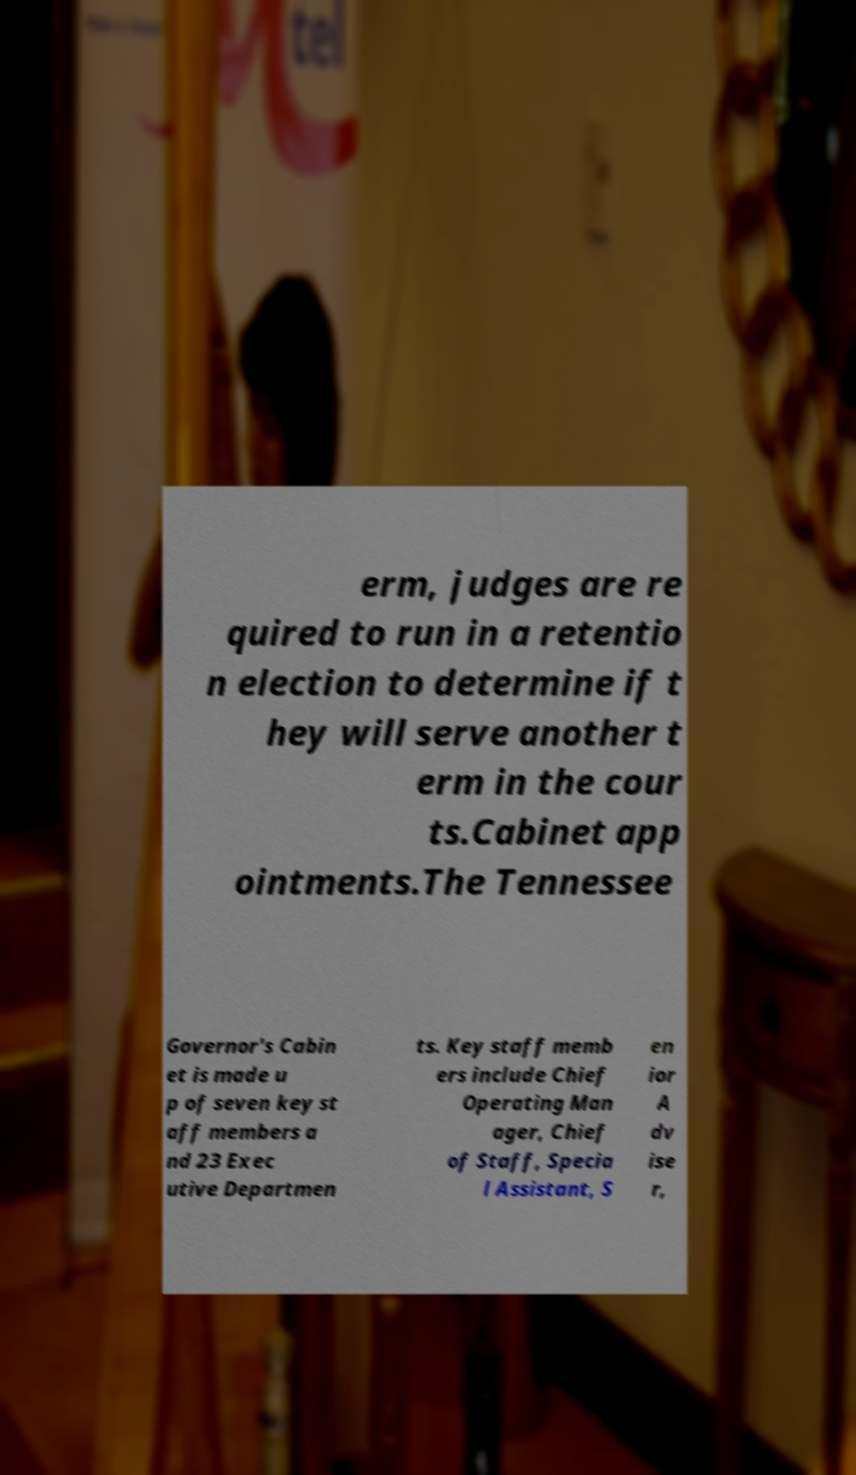Can you accurately transcribe the text from the provided image for me? erm, judges are re quired to run in a retentio n election to determine if t hey will serve another t erm in the cour ts.Cabinet app ointments.The Tennessee Governor's Cabin et is made u p of seven key st aff members a nd 23 Exec utive Departmen ts. Key staff memb ers include Chief Operating Man ager, Chief of Staff, Specia l Assistant, S en ior A dv ise r, 